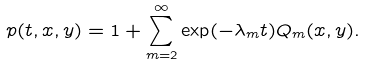<formula> <loc_0><loc_0><loc_500><loc_500>p ( t , x , y ) = 1 + \sum _ { m = 2 } ^ { \infty } \exp ( - \lambda _ { m } t ) Q _ { m } ( x , y ) .</formula> 